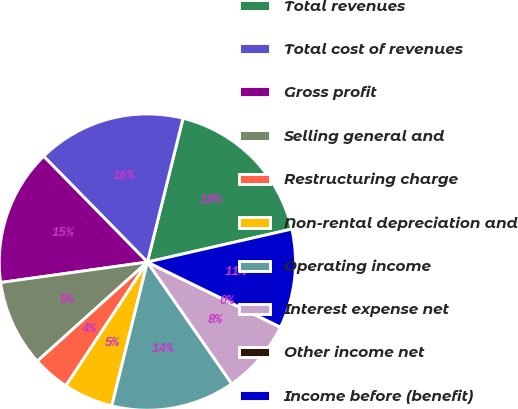<chart> <loc_0><loc_0><loc_500><loc_500><pie_chart><fcel>Total revenues<fcel>Total cost of revenues<fcel>Gross profit<fcel>Selling general and<fcel>Restructuring charge<fcel>Non-rental depreciation and<fcel>Operating income<fcel>Interest expense net<fcel>Other income net<fcel>Income before (benefit)<nl><fcel>17.56%<fcel>16.21%<fcel>14.86%<fcel>9.46%<fcel>4.06%<fcel>5.41%<fcel>13.51%<fcel>8.11%<fcel>0.01%<fcel>10.81%<nl></chart> 